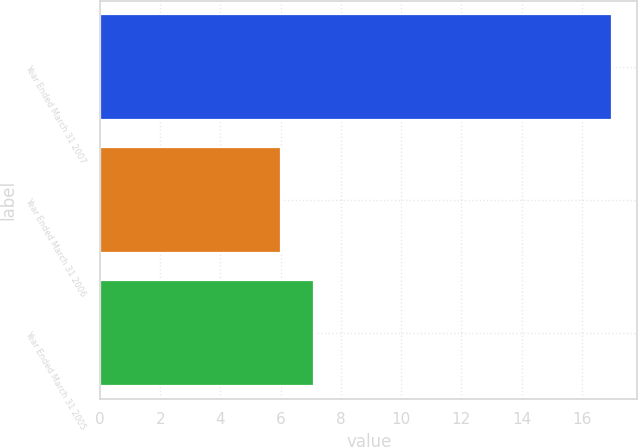<chart> <loc_0><loc_0><loc_500><loc_500><bar_chart><fcel>Year Ended March 31 2007<fcel>Year Ended March 31 2006<fcel>Year Ended March 31 2005<nl><fcel>17<fcel>6<fcel>7.1<nl></chart> 